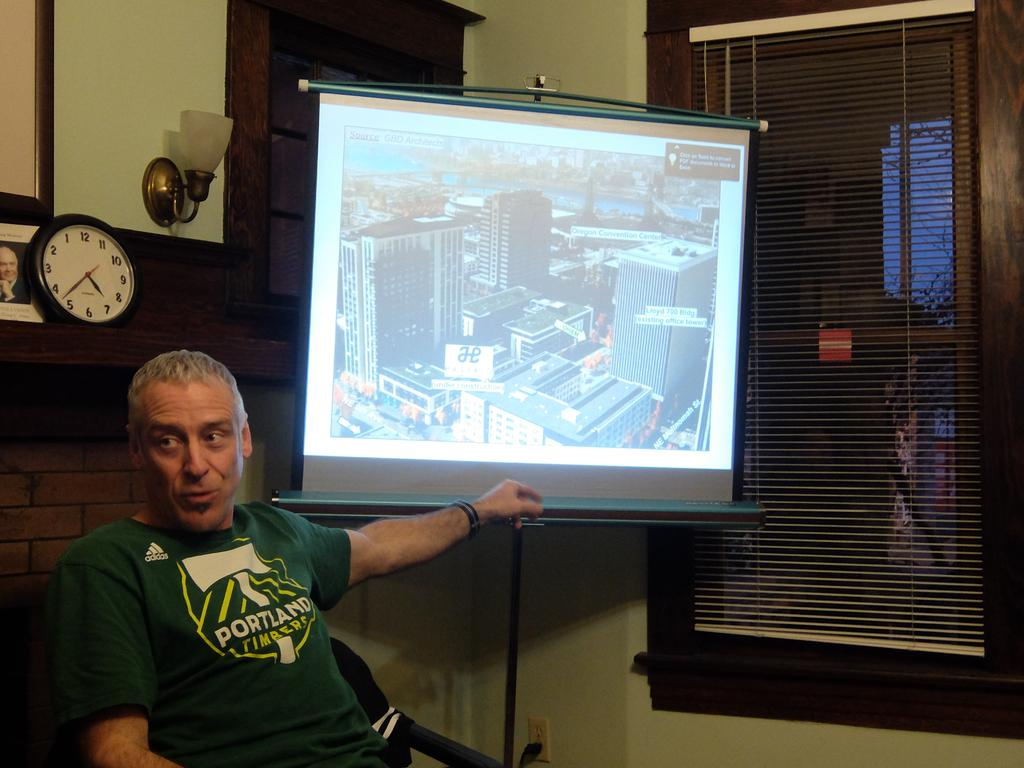<image>
Relay a brief, clear account of the picture shown. A man wearing a green Portland shirt sits right under a black and white clock. 